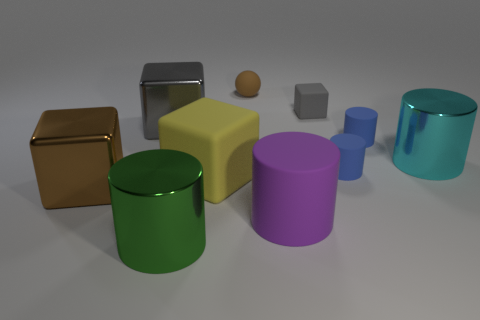What number of cubes have the same size as the cyan metallic thing?
Your answer should be very brief. 3. What number of things are either tiny objects or matte blocks that are to the right of the large purple matte cylinder?
Make the answer very short. 4. What is the shape of the big brown object?
Keep it short and to the point. Cube. What is the color of the matte cube that is the same size as the cyan cylinder?
Provide a short and direct response. Yellow. How many blue objects are blocks or metal balls?
Provide a short and direct response. 0. Is the number of cyan shiny cylinders greater than the number of small shiny cylinders?
Make the answer very short. Yes. Is the size of the blue cylinder in front of the big cyan shiny object the same as the shiny cylinder to the left of the cyan object?
Provide a succinct answer. No. There is a metal cylinder right of the block behind the gray cube that is left of the big purple matte thing; what is its color?
Provide a succinct answer. Cyan. Is there another big thing of the same shape as the cyan object?
Give a very brief answer. Yes. Are there more large yellow blocks that are in front of the tiny matte cube than big blue spheres?
Offer a very short reply. Yes. 